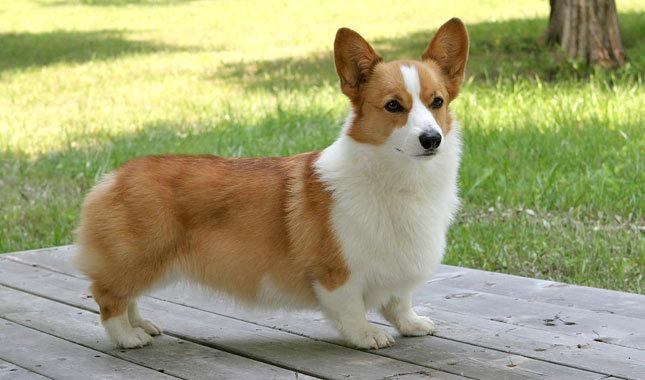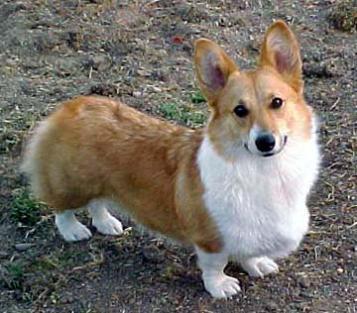The first image is the image on the left, the second image is the image on the right. Analyze the images presented: Is the assertion "One of the images shows two corgis in close proximity to each other." valid? Answer yes or no. No. The first image is the image on the left, the second image is the image on the right. Considering the images on both sides, is "There are at most two corgis." valid? Answer yes or no. Yes. 